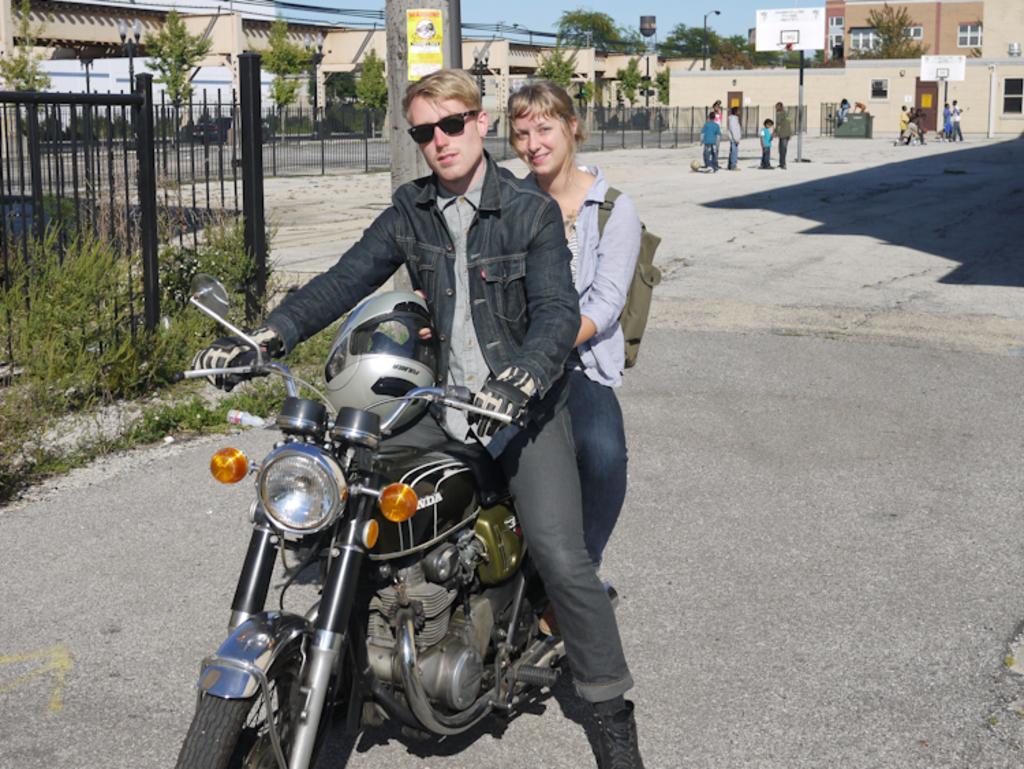In one or two sentences, can you explain what this image depicts? There is a man wearing a goggles and gloves is sitting on a bike. Behind him there is a lady wearing a bag is sitting. There is a helmet on the bike. Beside them there is a railings and plants on the sidewalk. In the background there are building with windows, trees, basketball court, basketball net. Some people are standing. There are many trees. 